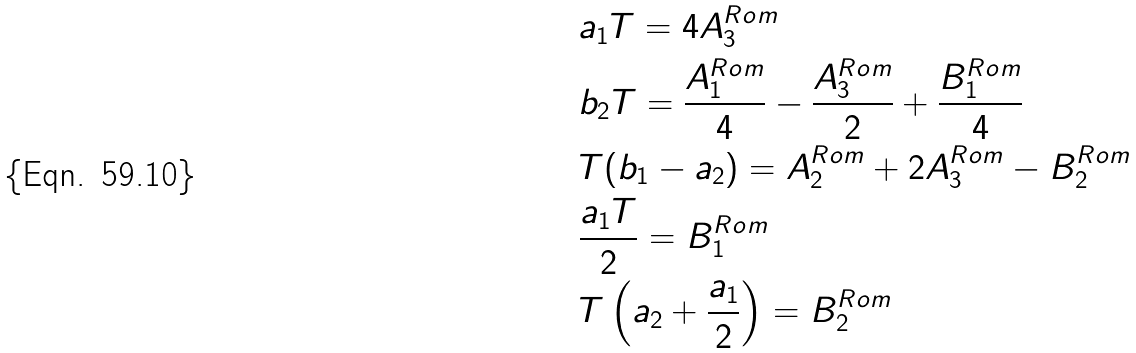Convert formula to latex. <formula><loc_0><loc_0><loc_500><loc_500>& a _ { 1 } T = 4 A ^ { R o m } _ { 3 } \\ & b _ { 2 } T = \frac { A ^ { R o m } _ { 1 } } { 4 } - \frac { A ^ { R o m } _ { 3 } } { 2 } + \frac { B ^ { R o m } _ { 1 } } { 4 } \\ & T ( b _ { 1 } - a _ { 2 } ) = A ^ { R o m } _ { 2 } + 2 A ^ { R o m } _ { 3 } - B ^ { R o m } _ { 2 } \\ & \frac { a _ { 1 } T } { 2 } = B ^ { R o m } _ { 1 } \\ & T \left ( a _ { 2 } + \frac { a _ { 1 } } { 2 } \right ) = B ^ { R o m } _ { 2 } \\</formula> 